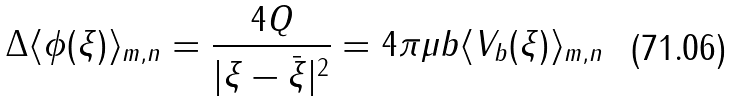<formula> <loc_0><loc_0><loc_500><loc_500>\Delta \langle \phi ( \xi ) \rangle _ { m , n } = \frac { 4 Q } { | \xi - \bar { \xi } | ^ { 2 } } = 4 \pi \mu b \langle V _ { b } ( \xi ) \rangle _ { m , n }</formula> 